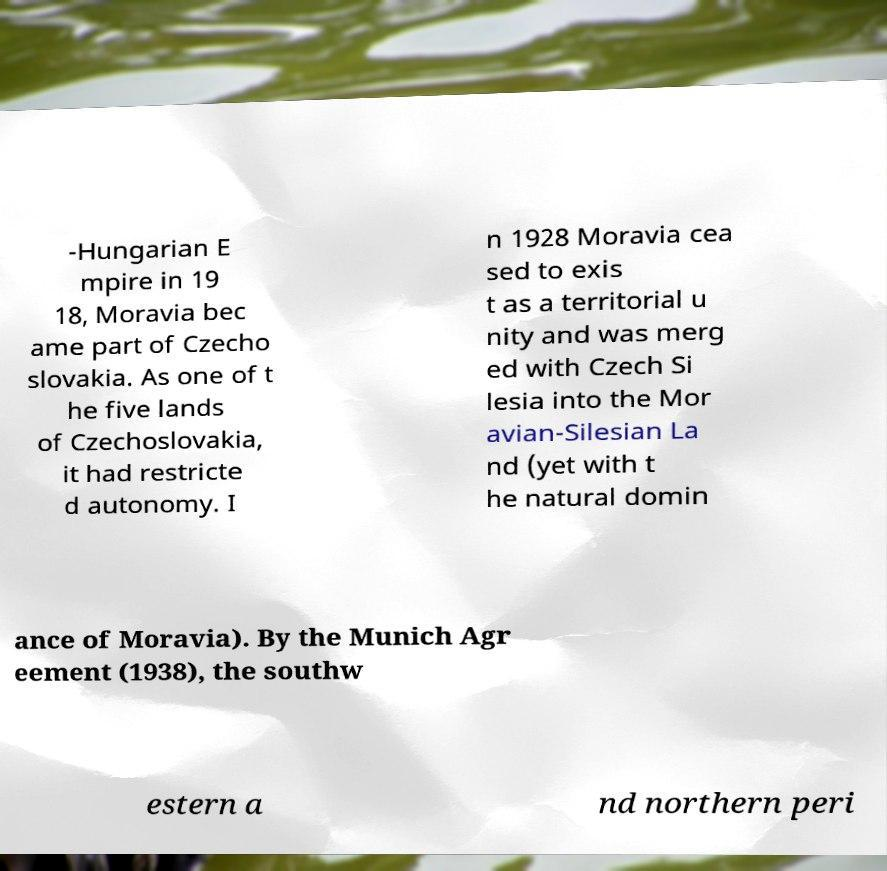What messages or text are displayed in this image? I need them in a readable, typed format. -Hungarian E mpire in 19 18, Moravia bec ame part of Czecho slovakia. As one of t he five lands of Czechoslovakia, it had restricte d autonomy. I n 1928 Moravia cea sed to exis t as a territorial u nity and was merg ed with Czech Si lesia into the Mor avian-Silesian La nd (yet with t he natural domin ance of Moravia). By the Munich Agr eement (1938), the southw estern a nd northern peri 